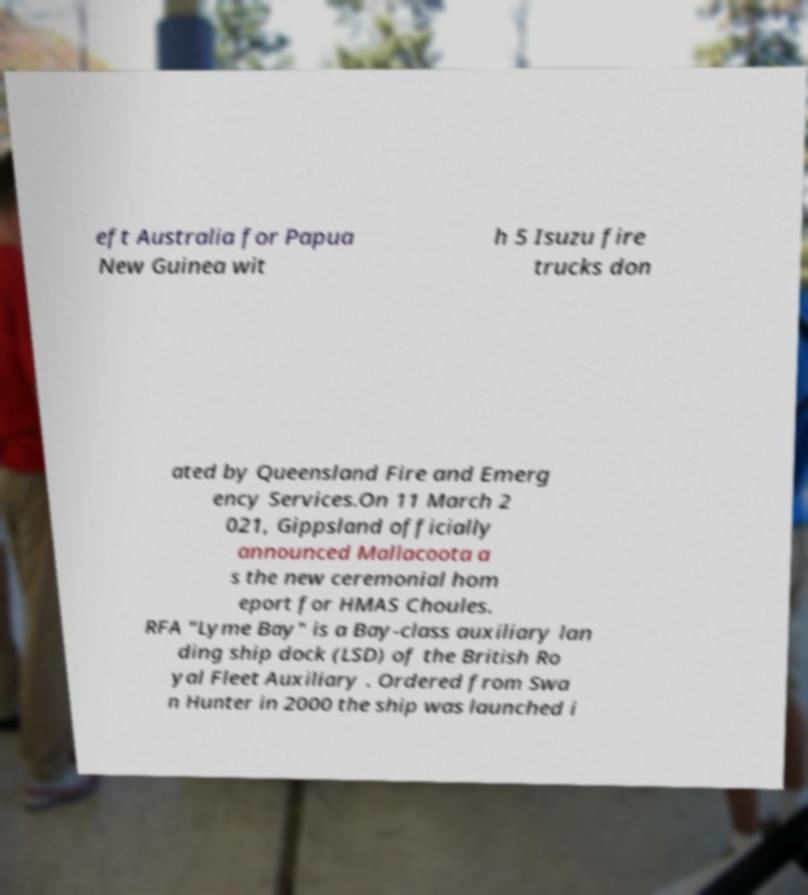Please identify and transcribe the text found in this image. eft Australia for Papua New Guinea wit h 5 Isuzu fire trucks don ated by Queensland Fire and Emerg ency Services.On 11 March 2 021, Gippsland officially announced Mallacoota a s the new ceremonial hom eport for HMAS Choules. RFA "Lyme Bay" is a Bay-class auxiliary lan ding ship dock (LSD) of the British Ro yal Fleet Auxiliary . Ordered from Swa n Hunter in 2000 the ship was launched i 